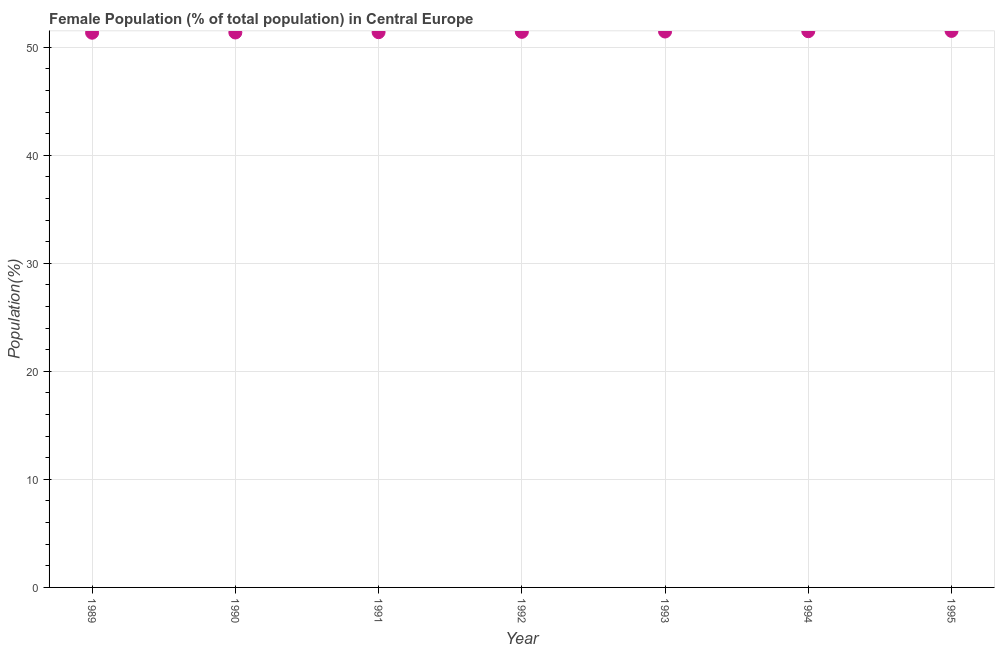What is the female population in 1993?
Provide a succinct answer. 51.45. Across all years, what is the maximum female population?
Your answer should be very brief. 51.51. Across all years, what is the minimum female population?
Your response must be concise. 51.34. In which year was the female population minimum?
Your answer should be compact. 1989. What is the sum of the female population?
Make the answer very short. 359.95. What is the difference between the female population in 1990 and 1993?
Ensure brevity in your answer.  -0.09. What is the average female population per year?
Keep it short and to the point. 51.42. What is the median female population?
Offer a very short reply. 51.42. What is the ratio of the female population in 1989 to that in 1995?
Your response must be concise. 1. Is the female population in 1990 less than that in 1993?
Offer a terse response. Yes. What is the difference between the highest and the second highest female population?
Provide a succinct answer. 0.03. Is the sum of the female population in 1989 and 1990 greater than the maximum female population across all years?
Offer a terse response. Yes. What is the difference between the highest and the lowest female population?
Provide a short and direct response. 0.17. What is the difference between two consecutive major ticks on the Y-axis?
Ensure brevity in your answer.  10. Does the graph contain any zero values?
Provide a short and direct response. No. What is the title of the graph?
Offer a very short reply. Female Population (% of total population) in Central Europe. What is the label or title of the Y-axis?
Your answer should be very brief. Population(%). What is the Population(%) in 1989?
Offer a terse response. 51.34. What is the Population(%) in 1990?
Make the answer very short. 51.36. What is the Population(%) in 1991?
Provide a short and direct response. 51.39. What is the Population(%) in 1992?
Provide a short and direct response. 51.42. What is the Population(%) in 1993?
Provide a succinct answer. 51.45. What is the Population(%) in 1994?
Your answer should be compact. 51.48. What is the Population(%) in 1995?
Offer a terse response. 51.51. What is the difference between the Population(%) in 1989 and 1990?
Offer a terse response. -0.02. What is the difference between the Population(%) in 1989 and 1991?
Offer a very short reply. -0.05. What is the difference between the Population(%) in 1989 and 1992?
Keep it short and to the point. -0.08. What is the difference between the Population(%) in 1989 and 1993?
Your answer should be compact. -0.11. What is the difference between the Population(%) in 1989 and 1994?
Your answer should be compact. -0.14. What is the difference between the Population(%) in 1989 and 1995?
Make the answer very short. -0.17. What is the difference between the Population(%) in 1990 and 1991?
Offer a terse response. -0.03. What is the difference between the Population(%) in 1990 and 1992?
Give a very brief answer. -0.06. What is the difference between the Population(%) in 1990 and 1993?
Your response must be concise. -0.09. What is the difference between the Population(%) in 1990 and 1994?
Your answer should be compact. -0.12. What is the difference between the Population(%) in 1990 and 1995?
Make the answer very short. -0.14. What is the difference between the Population(%) in 1991 and 1992?
Ensure brevity in your answer.  -0.03. What is the difference between the Population(%) in 1991 and 1993?
Ensure brevity in your answer.  -0.06. What is the difference between the Population(%) in 1991 and 1994?
Make the answer very short. -0.09. What is the difference between the Population(%) in 1991 and 1995?
Your response must be concise. -0.12. What is the difference between the Population(%) in 1992 and 1993?
Provide a short and direct response. -0.03. What is the difference between the Population(%) in 1992 and 1994?
Your answer should be very brief. -0.06. What is the difference between the Population(%) in 1992 and 1995?
Your answer should be very brief. -0.09. What is the difference between the Population(%) in 1993 and 1994?
Your answer should be compact. -0.03. What is the difference between the Population(%) in 1993 and 1995?
Ensure brevity in your answer.  -0.06. What is the difference between the Population(%) in 1994 and 1995?
Your answer should be very brief. -0.03. What is the ratio of the Population(%) in 1989 to that in 1990?
Your answer should be compact. 1. What is the ratio of the Population(%) in 1989 to that in 1995?
Make the answer very short. 1. What is the ratio of the Population(%) in 1990 to that in 1993?
Ensure brevity in your answer.  1. What is the ratio of the Population(%) in 1990 to that in 1994?
Provide a succinct answer. 1. What is the ratio of the Population(%) in 1991 to that in 1993?
Make the answer very short. 1. What is the ratio of the Population(%) in 1991 to that in 1994?
Offer a terse response. 1. What is the ratio of the Population(%) in 1991 to that in 1995?
Keep it short and to the point. 1. What is the ratio of the Population(%) in 1992 to that in 1994?
Give a very brief answer. 1. 